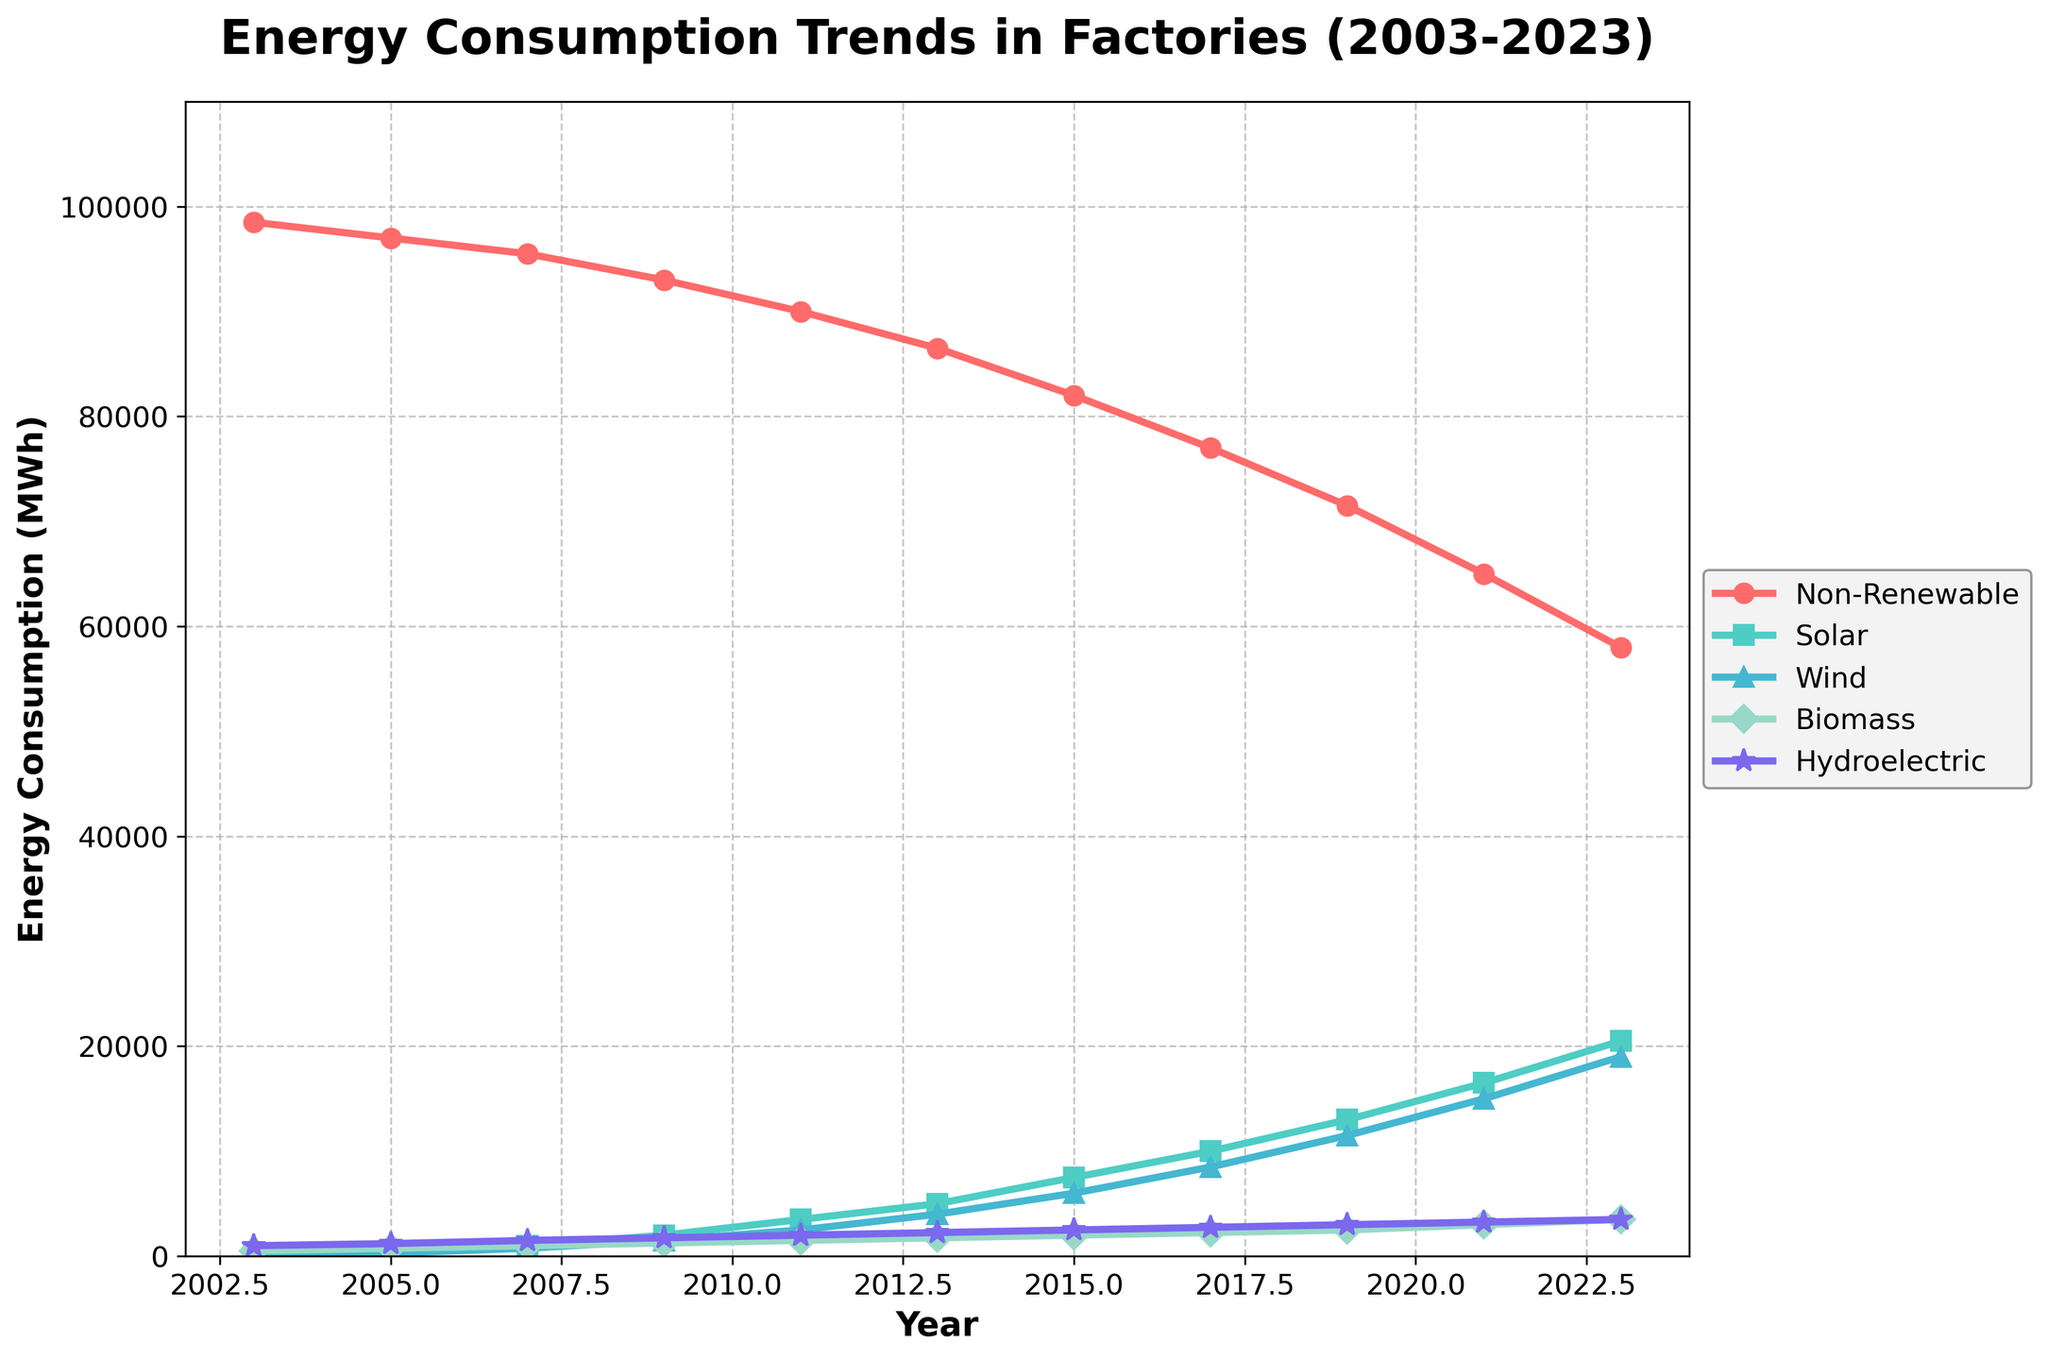What is the trend in non-renewable energy consumption from 2003 to 2023? By examining the line representing non-renewable energy, we can see a consistent decline over the 20 years from 98,500 MWh in 2003 to 58,000 MWh in 2023.
Answer: Declining How does solar energy consumption in 2023 compare to that in 2003? The line for solar energy consumption shows that it has increased from 250 MWh in 2003 to 20,500 MWh in 2023.
Answer: Increased Which year had the highest total renewable energy consumption when combining solar, wind, biomass, and hydroelectric energies? By adding up the renewable energy sources for each year, we find that 2023 has the highest total with 20,500 (Solar) + 19,000 (Wind) + 3,500 (Biomass) + 3,500 (Hydroelectric) = 46,500 MWh.
Answer: 2023 What is the difference in wind energy consumption between 2009 and 2019? Wind energy consumption in 2009 was 1,500 MWh, and in 2019, it was 11,500 MWh. So, the difference is 11,500 - 1,500 = 10,000 MWh.
Answer: 10,000 MWh Which type of renewable energy has seen the most growth from 2003 to 2023? By comparing the 2003 and 2023 values for each renewable energy type, solar energy has the most significant increase from 250 MWh to 20,500 MWh, which is a 20,250 MWh increase.
Answer: Solar How does the trend in biomass energy compare to the trend in non-renewable energy from 2003 to 2023? Biomass energy has shown a steady increase from 500 MWh in 2003 to 3,500 MWh in 2023, contrasting with the steady decline in non-renewable energy from 98,500 MWh to 58,000 MWh during the same period.
Answer: Biomass increasing, non-renewable decreasing What is the average annual increase in hydroelectric energy consumption from 2003 to 2023? The hydroelectric energy increases from 1,000 MWh in 2003 to 3,500 MWh in 2023. The total increase is 2,500 MWh over 20 years, so the average annual increase is 2,500 / 20 = 125 MWh per year.
Answer: 125 MWh per year In which year did solar and wind energy consumption become equal for the first time, and what was the value? Solar and wind energy consumption lines intersect in 2015 at approximately 7,500 MWh.
Answer: 2015, 7,500 MWh Compare the consumption of wind energy in 2017 and 2019. Which year had higher consumption, and by how much? Wind energy consumption in 2017 was 8,500 MWh, and in 2019, it was 11,500 MWh. The difference is 11,500 - 8,500 = 3,000 MWh. 2019 had higher consumption.
Answer: 2019 by 3,000 MWh 